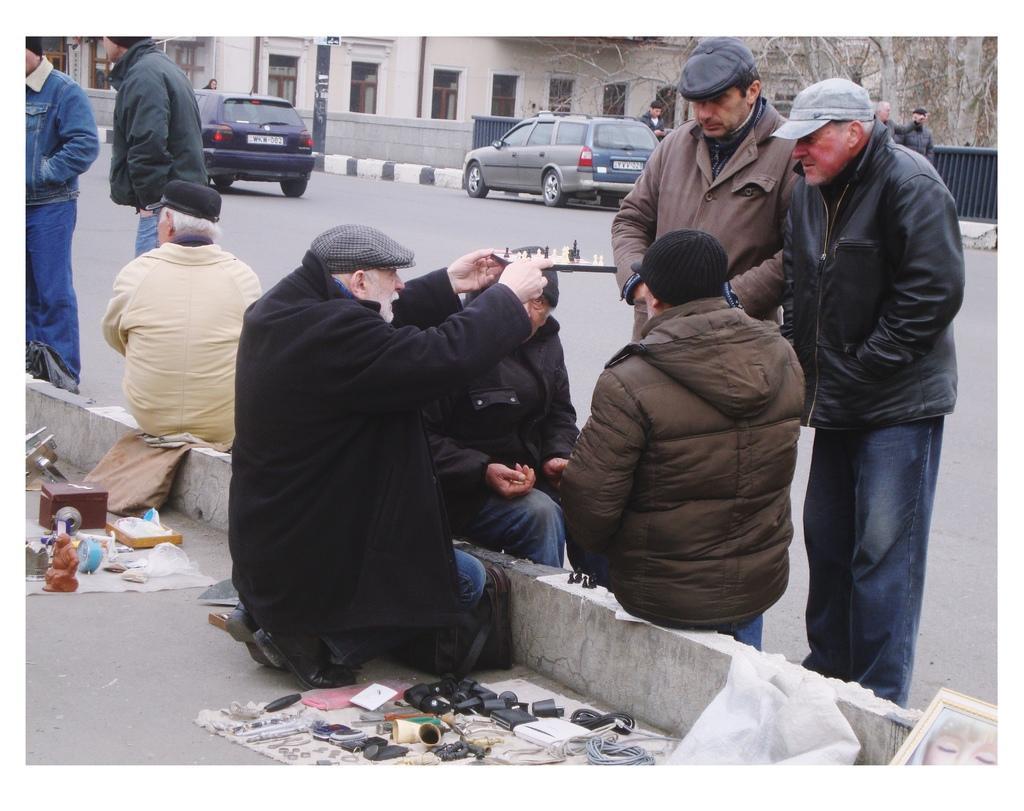Please provide a concise description of this image. Here we can see a man is in squat position on the road by holding a board in his hand and there are two men sitting on a platform and there are two men standing on the road and on the left there is a man sitting on a platform and two persons are standing on the road. At the bottom we can see some items,bags and some other items on a cloth on the road. In the background there are vehicles,few persons,building,windows and other objects. 